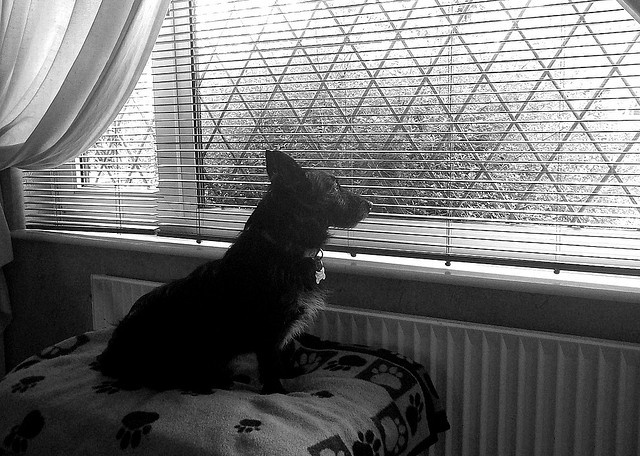Describe the objects in this image and their specific colors. I can see dog in darkgray, black, gray, and lightgray tones and bed in black, gray, and darkgray tones in this image. 